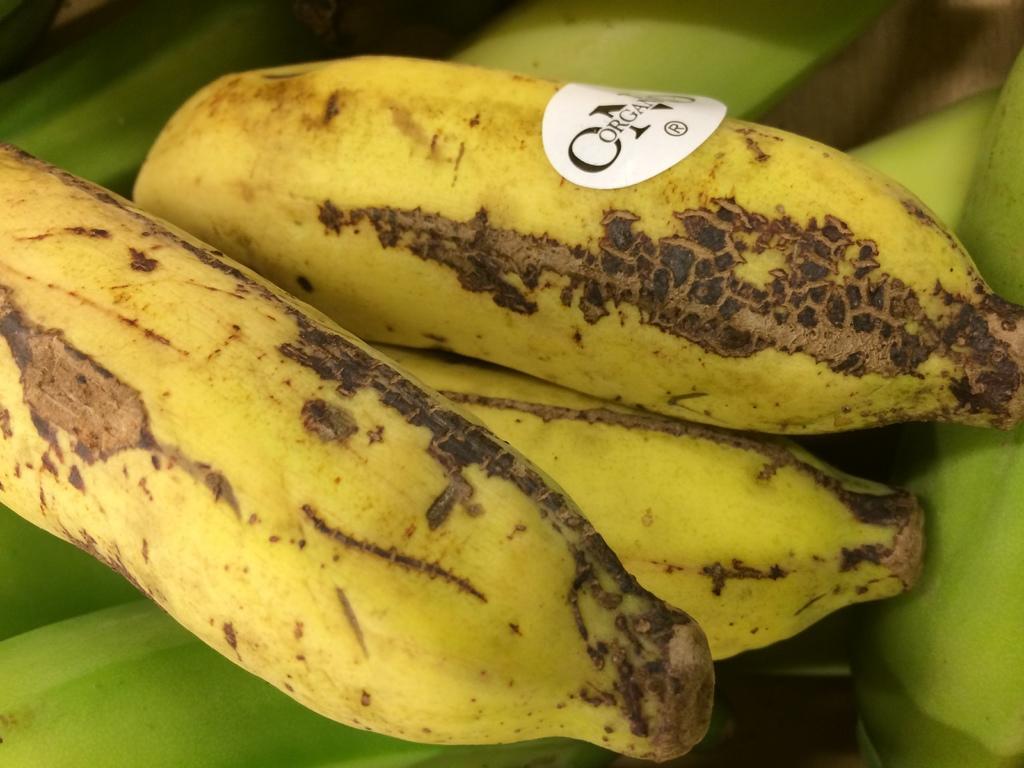In one or two sentences, can you explain what this image depicts? In this image we can see some bananas, also we can see a sticker on one banana with text on it. 